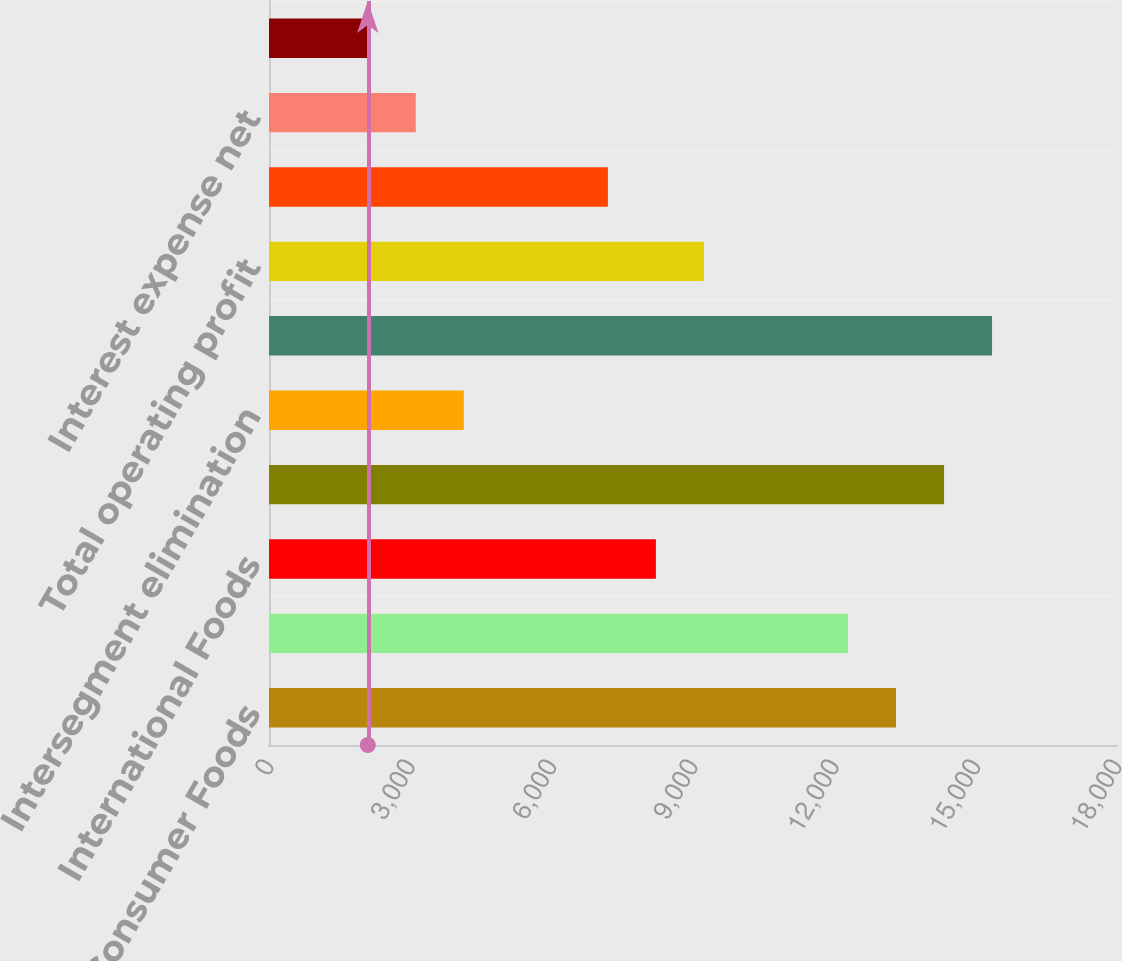Convert chart to OTSL. <chart><loc_0><loc_0><loc_500><loc_500><bar_chart><fcel>Consumer Foods<fcel>Food and Ingredients<fcel>International Foods<fcel>Total<fcel>Intersegment elimination<fcel>Total net sales<fcel>Total operating profit<fcel>General corporate expenses<fcel>Interest expense net<fcel>Income tax expense<nl><fcel>13309.4<fcel>12290<fcel>8212.76<fcel>14328.7<fcel>4135.48<fcel>15348<fcel>9232.08<fcel>7193.44<fcel>3116.16<fcel>2096.84<nl></chart> 